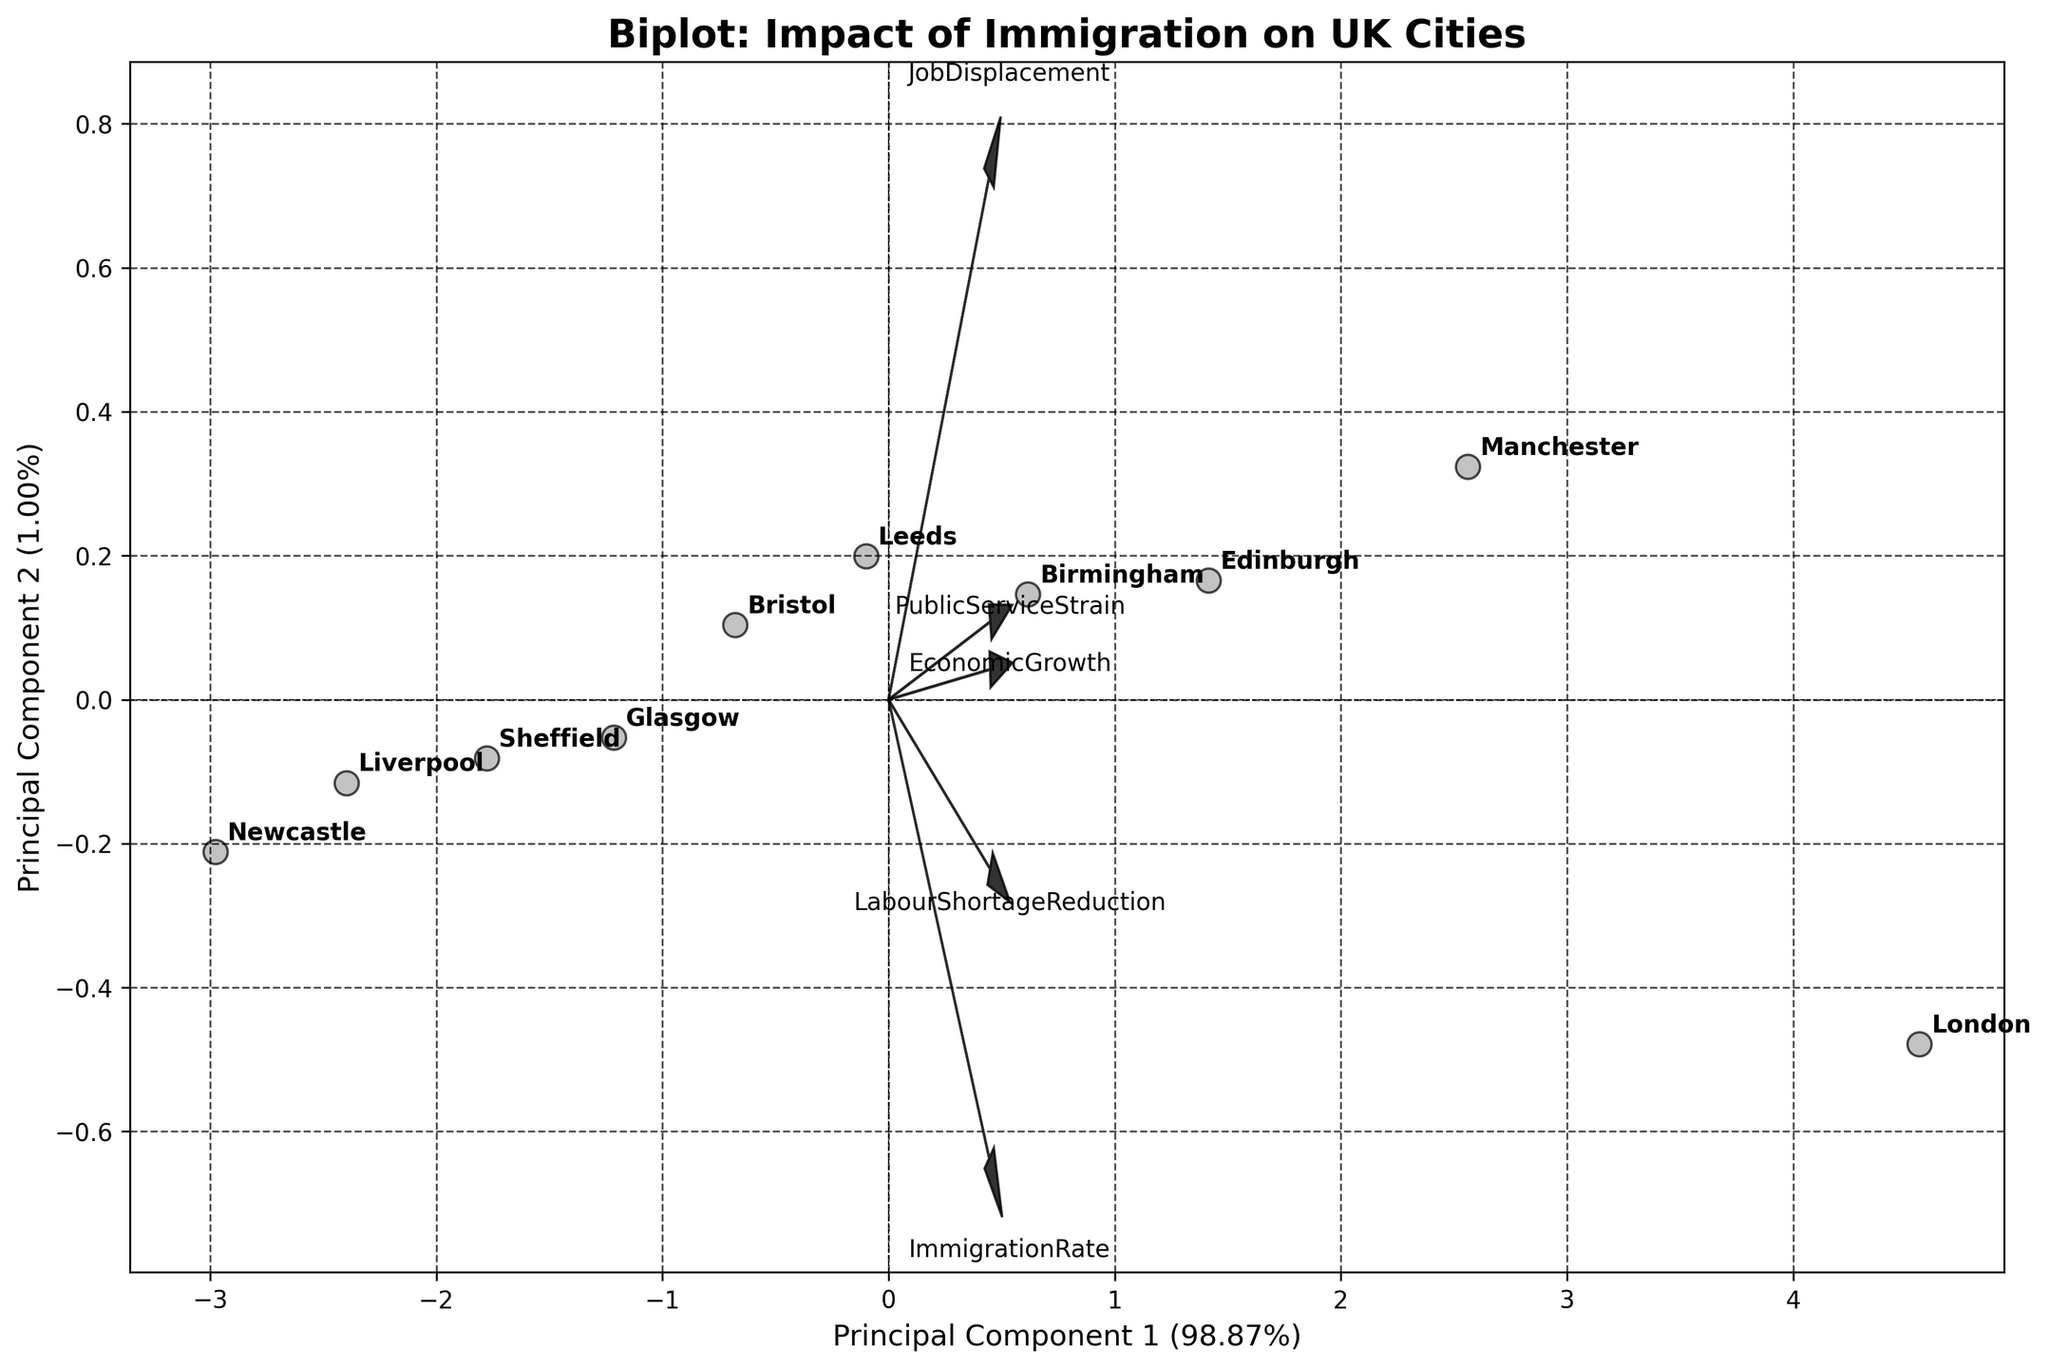What's the title of the plot? The title of the plot is typically displayed at the top center of the figure. For this plot, the title clearly states its purpose and focus.
Answer: Biplot: Impact of Immigration on UK Cities Which city is located furthest to the right on Principal Component 1? To determine this, we look at the city located at the extreme right end of the horizontal axis labeled as Principal Component 1.
Answer: London Which feature has the longest vector in the plot? The feature with the longest vector is identified by checking the length of the arrows emanating from the origin. The longest arrow indicates the feature with the most influence.
Answer: ImmigrationRate Which two cities are closest to each other in the biplot? To find the two cities that are closest, we observe the plot and identify the pair of cities that are located nearest to each other in the two-dimensional PCA space.
Answer: Birmingham and Leeds How does the 'LabourShortageReduction' feature align relative to Principal Component 2? We need to observe the direction of the 'LabourShortageReduction' vector and its alignment with the vertical axis labeled as Principal Component 2.
Answer: Positive direction On Principal Component 1, which city is further to the left: Liverpool or Newcastle? We compare the positions of Liverpool and Newcastle along the horizontal axis (Principal Component 1) to see which is further left.
Answer: Newcastle Explain the relationship between 'EconomicGrowth' and 'ImmigrationRate' based on the biplot. To understand their relationship, we look at the direction and proximity of their vectors. Vectors that point in similar directions indicate a positive correlation, while those in opposite directions suggest a negative correlation.
Answer: Positive correlation Which cities are on the negative side of Principal Component 2? Cities on the negative side of Principal Component 2 are those located below the horizontal axis (Principal Component 2 = 0).
Answer: Liverpool, Newcastle Do cities with higher 'PublicServiceStrain' exhibit similar principal component space characteristics? We check the direction of the 'PublicServiceStrain' vector and see if cities known for high strain are positioned along that vector in the PCA space.
Answer: Yes What's the percentage explained by Principal Component 2? This percentage is given on the axis label for Principal Component 2, usually indicating how much of the total variance is captured by it.
Answer: 24% 